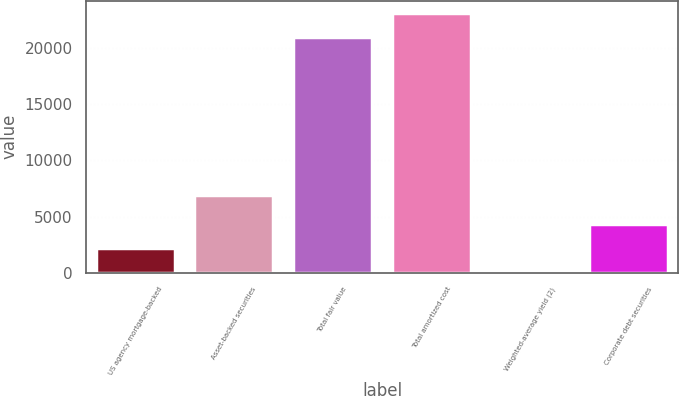Convert chart to OTSL. <chart><loc_0><loc_0><loc_500><loc_500><bar_chart><fcel>US agency mortgage-backed<fcel>Asset-backed securities<fcel>Total fair value<fcel>Total amortized cost<fcel>Weighted-average yield (2)<fcel>Corporate debt securities<nl><fcel>2253<fcel>6924<fcel>20960<fcel>23059.7<fcel>1.63<fcel>4352.74<nl></chart> 